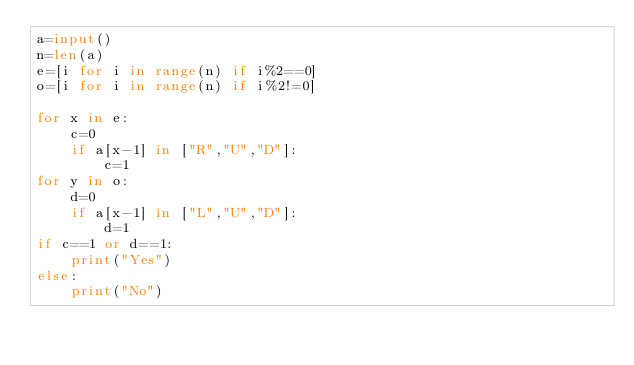Convert code to text. <code><loc_0><loc_0><loc_500><loc_500><_Python_>a=input()
n=len(a)
e=[i for i in range(n) if i%2==0]
o=[i for i in range(n) if i%2!=0]

for x in e:
    c=0
    if a[x-1] in ["R","U","D"]:
        c=1
for y in o:
    d=0
    if a[x-1] in ["L","U","D"]:
        d=1
if c==1 or d==1:
    print("Yes")
else:
    print("No")</code> 